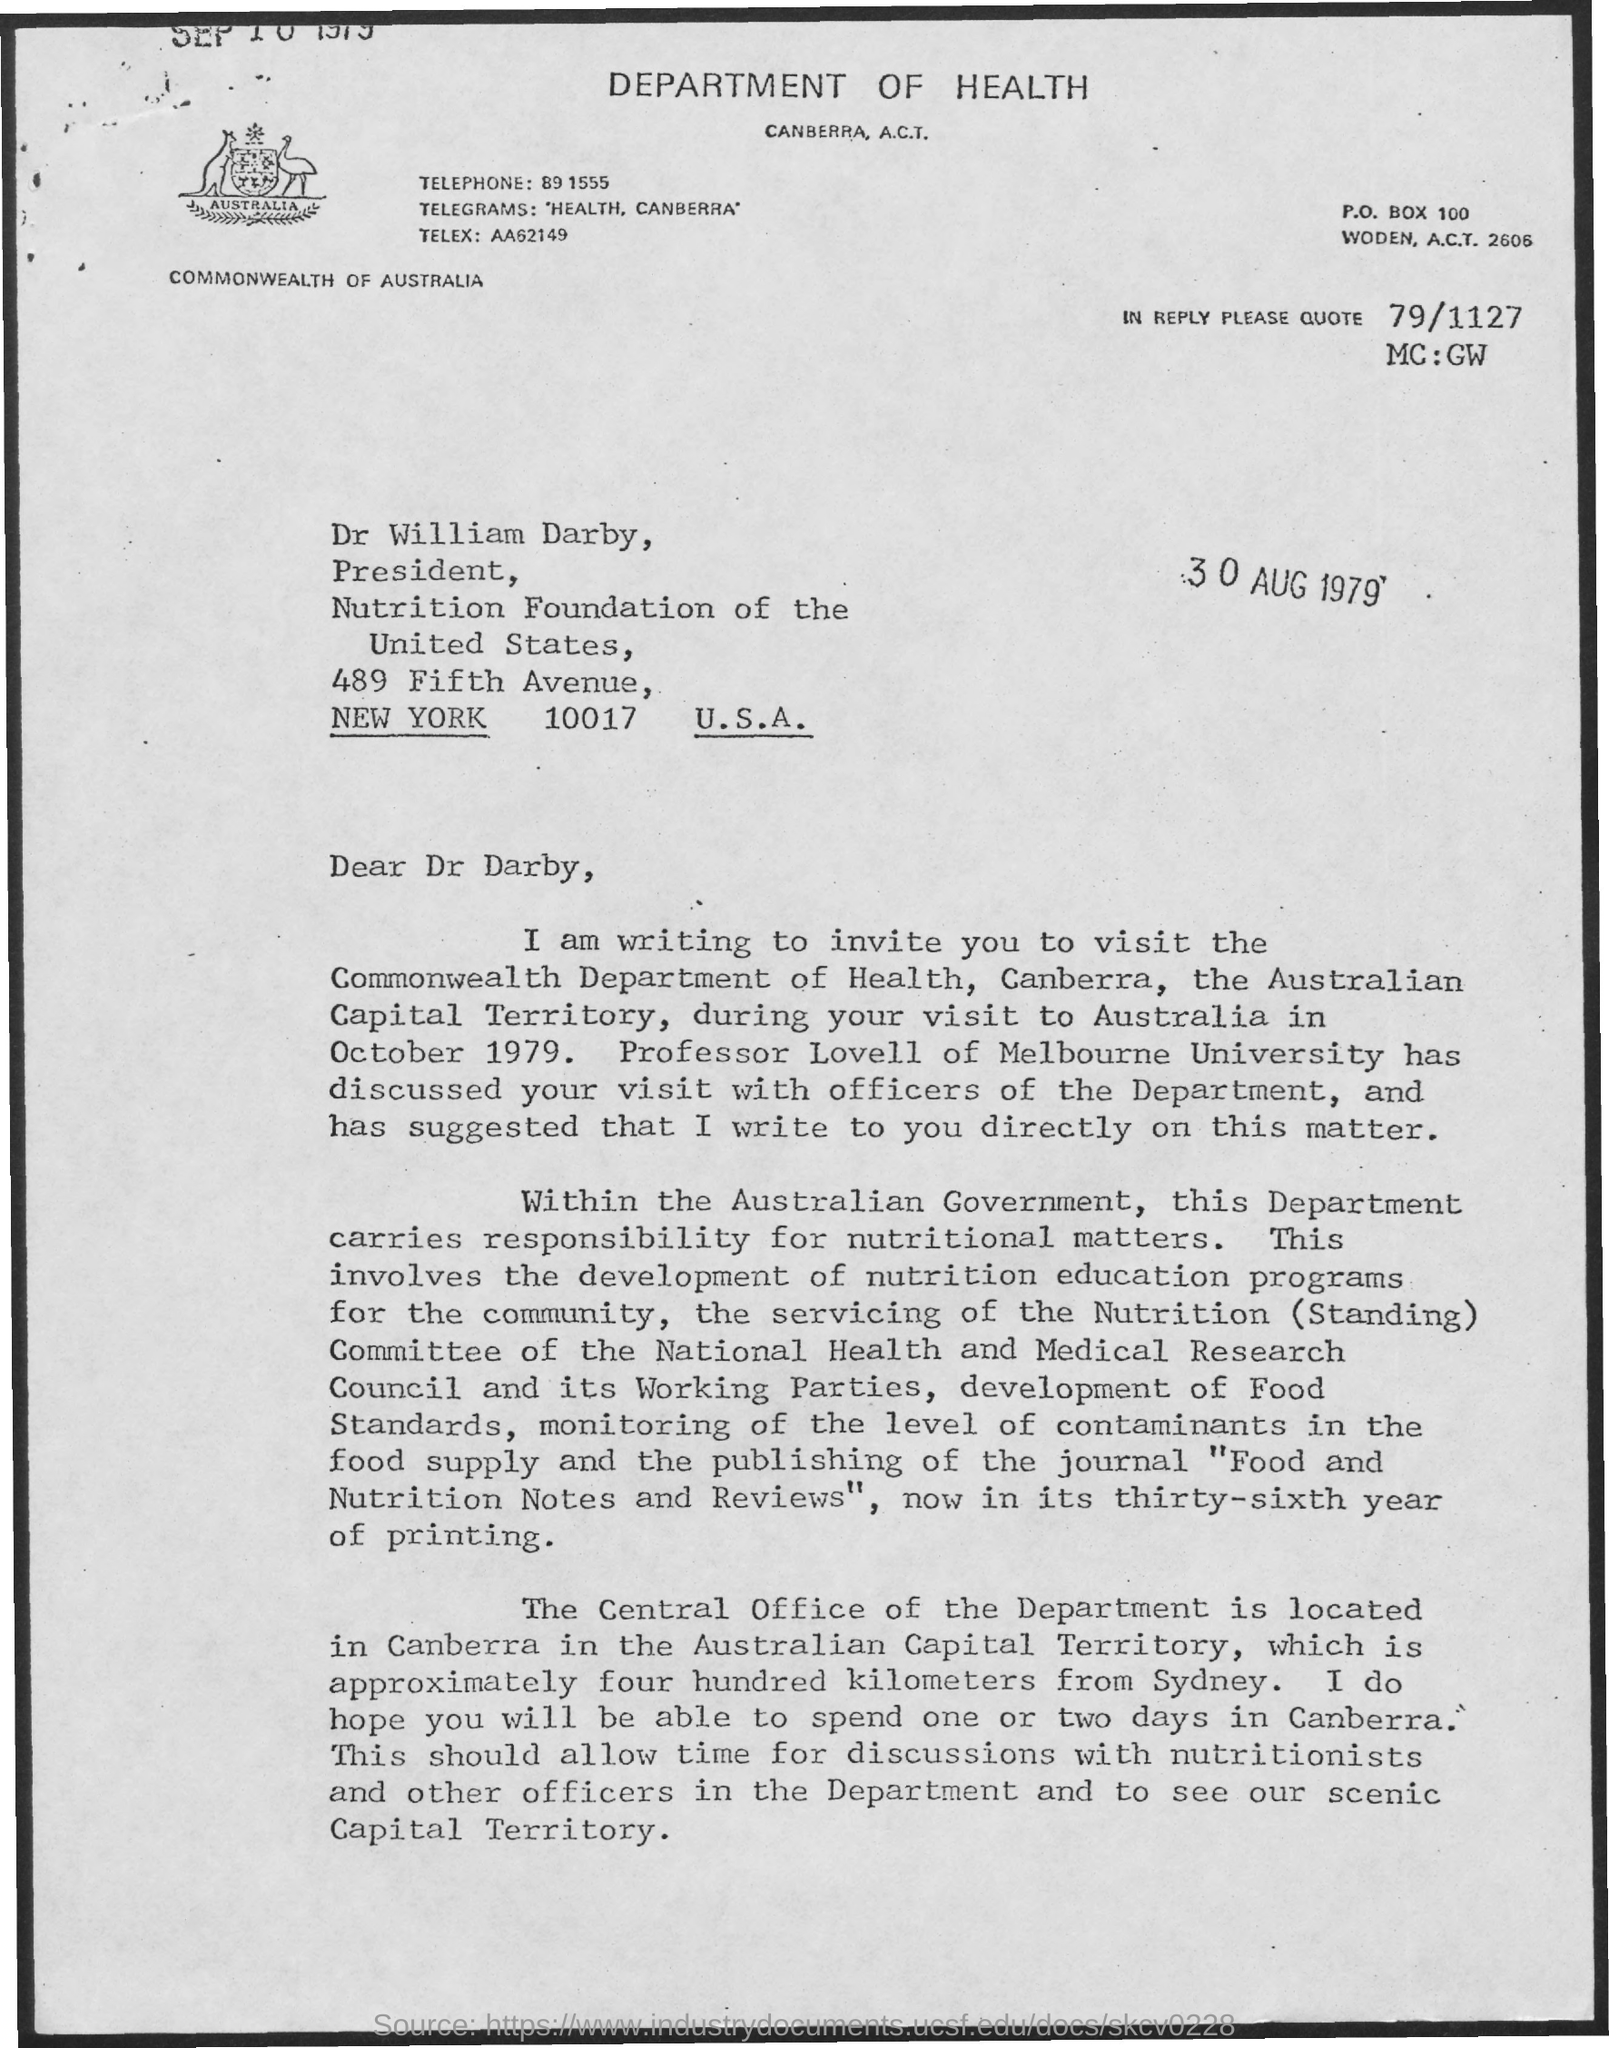Point out several critical features in this image. The city mentioned is New York. The president of the Nutrition Foundation of the United States is Dr. William Darby. The P.O. Box number is 100. 